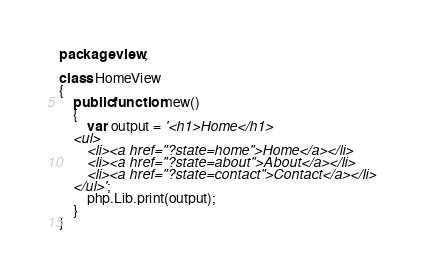Convert code to text. <code><loc_0><loc_0><loc_500><loc_500><_Haxe_>package view;

class HomeView 
{
	public function new() 
	{
		var output = '<h1>Home</h1>
	<ul>
		<li><a href="?state=home">Home</a></li>
		<li><a href="?state=about">About</a></li>
		<li><a href="?state=contact">Contact</a></li>
	</ul>';
		php.Lib.print(output);
	}
}</code> 